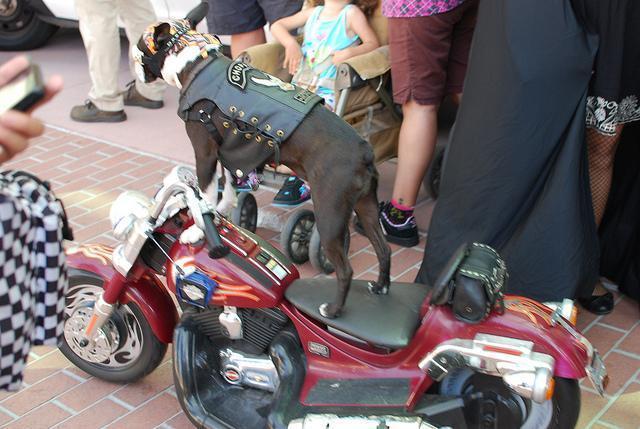How many cars are there out there?
Give a very brief answer. 0. How many wheels does this vehicle have?
Give a very brief answer. 2. How many people are there?
Give a very brief answer. 5. How many bikes are in this photo?
Give a very brief answer. 0. 